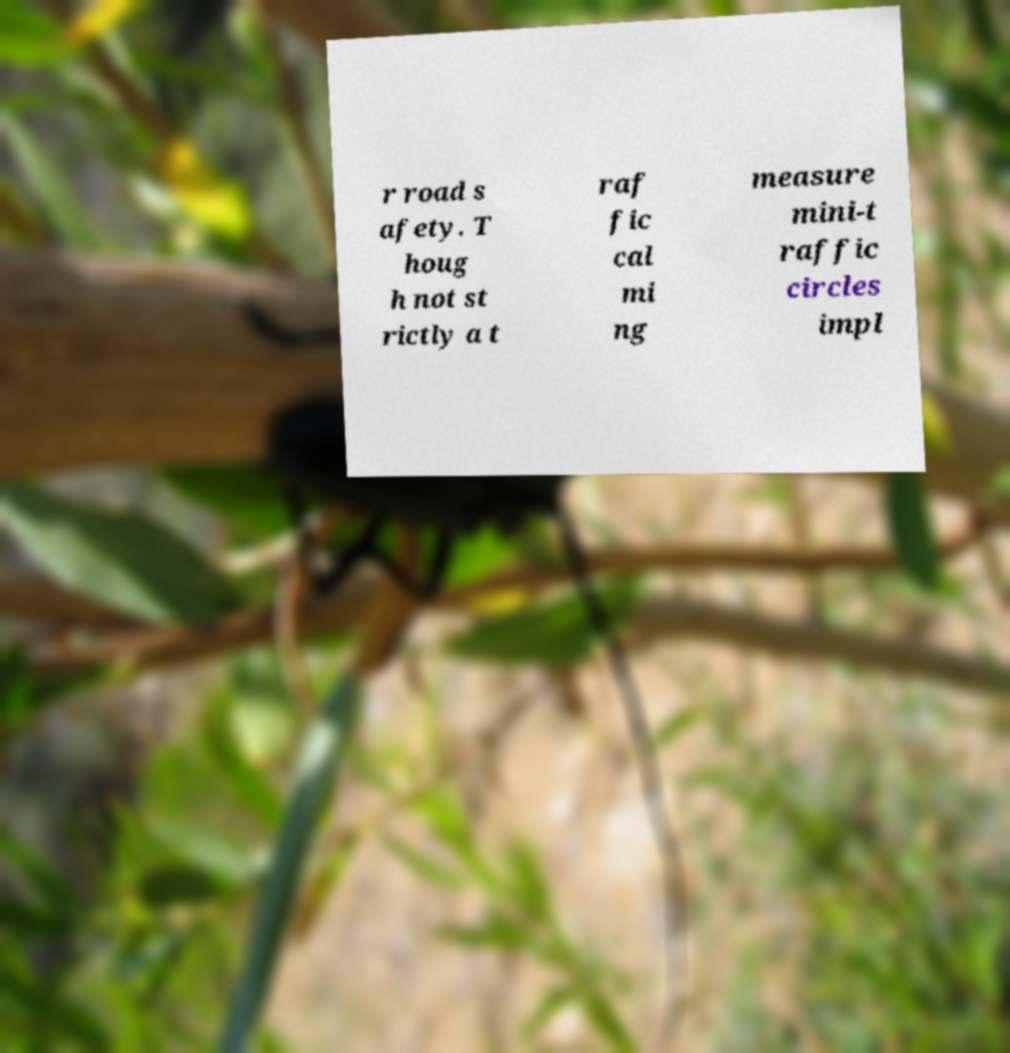What messages or text are displayed in this image? I need them in a readable, typed format. r road s afety. T houg h not st rictly a t raf fic cal mi ng measure mini-t raffic circles impl 